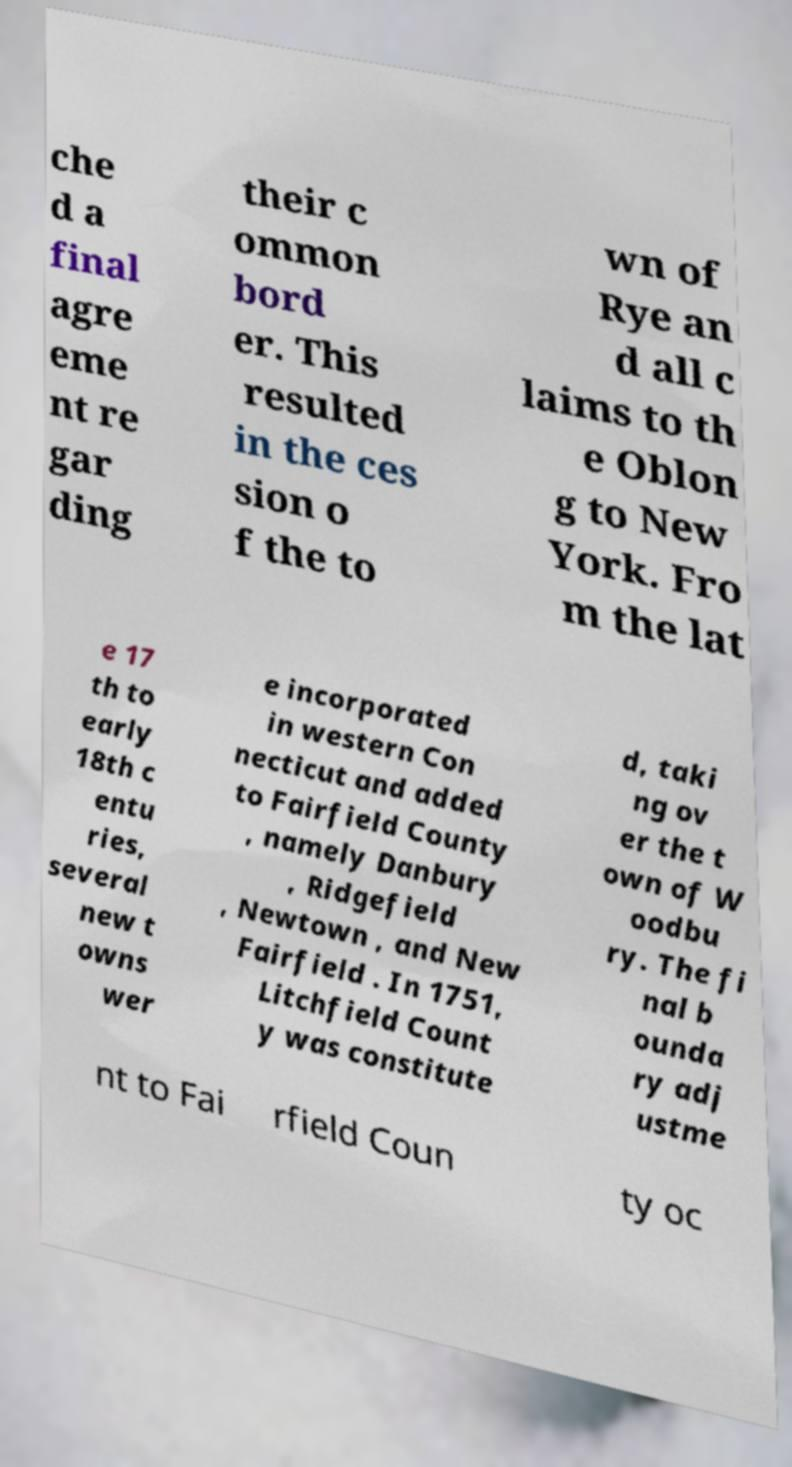Can you accurately transcribe the text from the provided image for me? che d a final agre eme nt re gar ding their c ommon bord er. This resulted in the ces sion o f the to wn of Rye an d all c laims to th e Oblon g to New York. Fro m the lat e 17 th to early 18th c entu ries, several new t owns wer e incorporated in western Con necticut and added to Fairfield County , namely Danbury , Ridgefield , Newtown , and New Fairfield . In 1751, Litchfield Count y was constitute d, taki ng ov er the t own of W oodbu ry. The fi nal b ounda ry adj ustme nt to Fai rfield Coun ty oc 